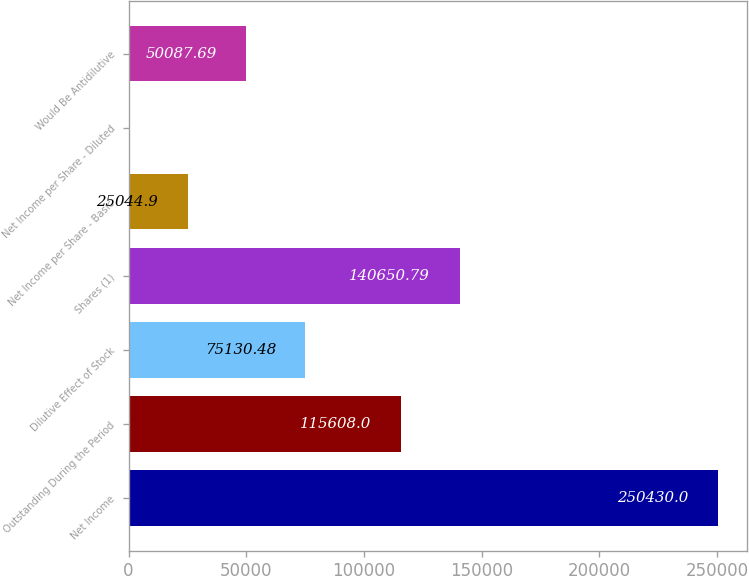Convert chart to OTSL. <chart><loc_0><loc_0><loc_500><loc_500><bar_chart><fcel>Net Income<fcel>Outstanding During the Period<fcel>Dilutive Effect of Stock<fcel>Shares (1)<fcel>Net Income per Share - Basic<fcel>Net Income per Share - Diluted<fcel>Would Be Antidilutive<nl><fcel>250430<fcel>115608<fcel>75130.5<fcel>140651<fcel>25044.9<fcel>2.11<fcel>50087.7<nl></chart> 